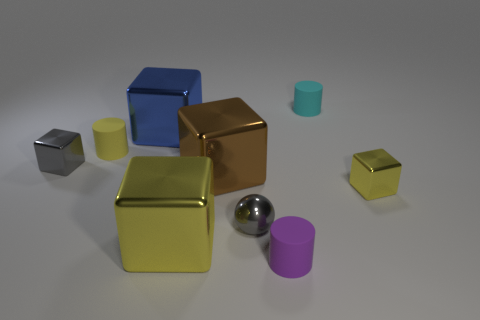What color is the other small shiny thing that is the same shape as the small yellow metal thing?
Your answer should be compact. Gray. There is a small yellow thing in front of the small yellow cylinder; does it have the same shape as the brown metallic thing?
Your response must be concise. Yes. What is the material of the cylinder that is behind the large yellow object and in front of the tiny cyan thing?
Your answer should be compact. Rubber. What is the material of the tiny yellow thing in front of the small metallic block to the left of the metallic ball?
Ensure brevity in your answer.  Metal. There is a yellow block that is in front of the gray thing to the right of the tiny block that is to the left of the big blue object; what size is it?
Your answer should be compact. Large. How many tiny yellow blocks are made of the same material as the large blue cube?
Your response must be concise. 1. What color is the tiny rubber object that is in front of the yellow block that is to the right of the tiny cyan thing?
Offer a terse response. Purple. What number of objects are tiny red matte things or yellow metallic things that are right of the sphere?
Provide a succinct answer. 1. Is there a tiny metal thing that has the same color as the sphere?
Ensure brevity in your answer.  Yes. How many purple things are big things or cylinders?
Offer a very short reply. 1. 